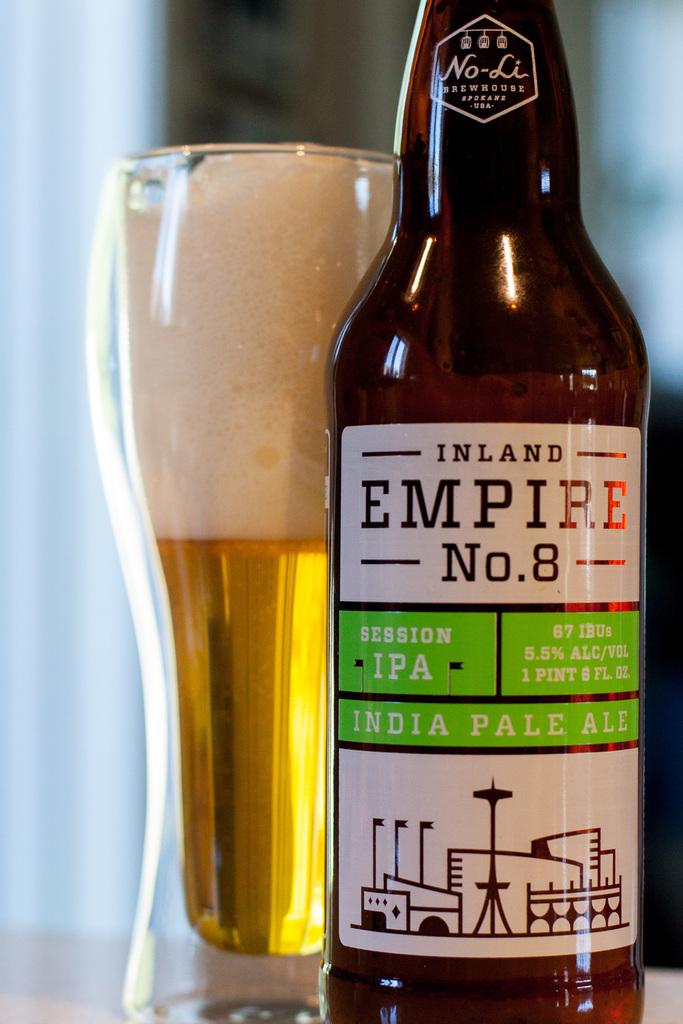How much alcohol by volume is in the bottle?
Your answer should be very brief. 5.5%. What type of ale is this?
Your answer should be very brief. India pale ale. 